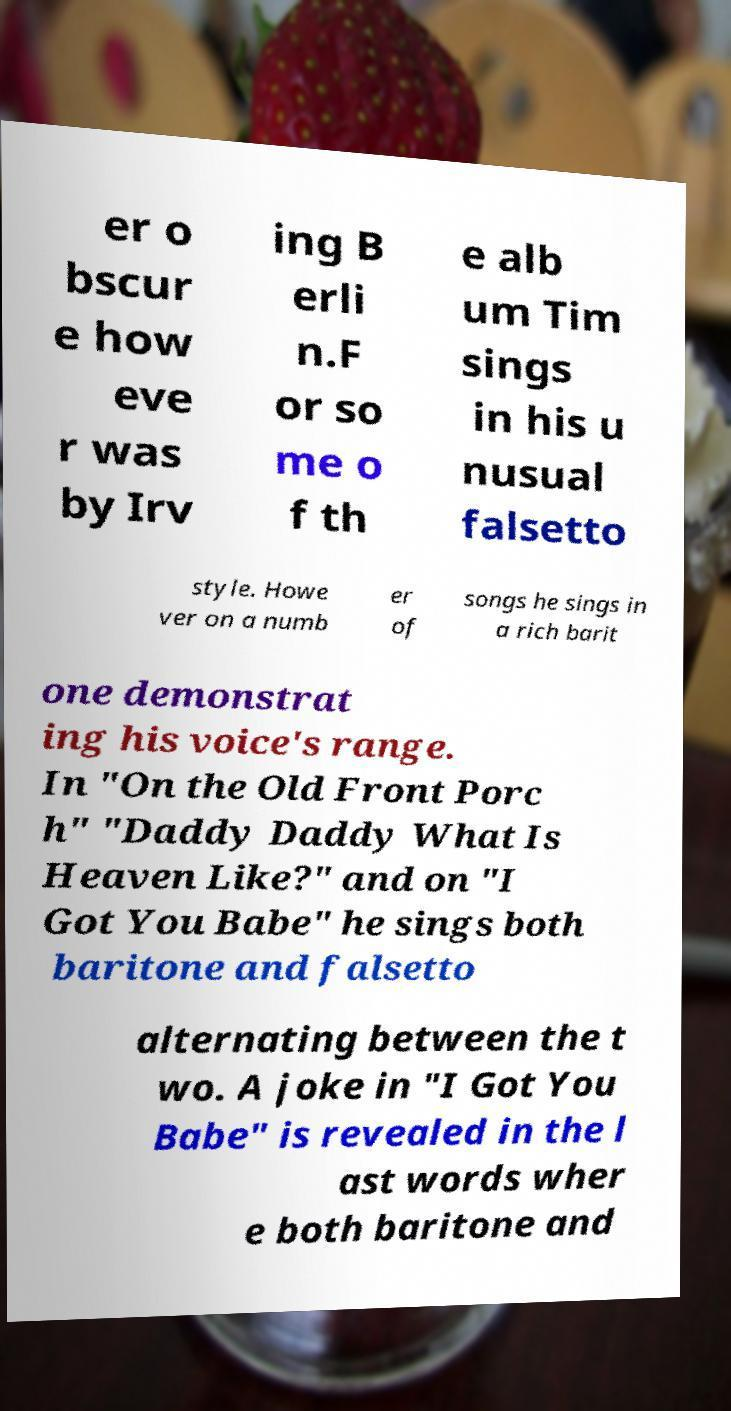There's text embedded in this image that I need extracted. Can you transcribe it verbatim? er o bscur e how eve r was by Irv ing B erli n.F or so me o f th e alb um Tim sings in his u nusual falsetto style. Howe ver on a numb er of songs he sings in a rich barit one demonstrat ing his voice's range. In "On the Old Front Porc h" "Daddy Daddy What Is Heaven Like?" and on "I Got You Babe" he sings both baritone and falsetto alternating between the t wo. A joke in "I Got You Babe" is revealed in the l ast words wher e both baritone and 